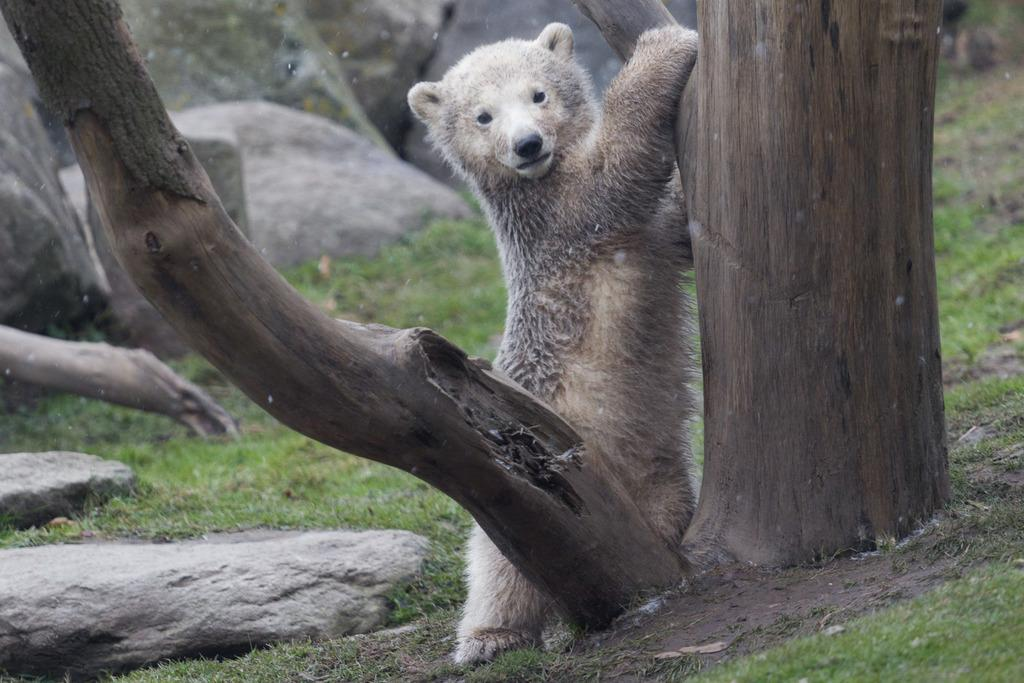What animal is the main subject of the picture? There is a polar bear in the picture. Where is the polar bear located in the image? The polar bear is on the ground. What type of vegetation can be seen in the image? There are trees and grass visible in the image. What other natural elements are present in the image? There are rocks in the image. What type of punishment is the polar bear receiving in the image? There is no indication of punishment in the image; it simply shows a polar bear on the ground with trees, grass, and rocks nearby. 